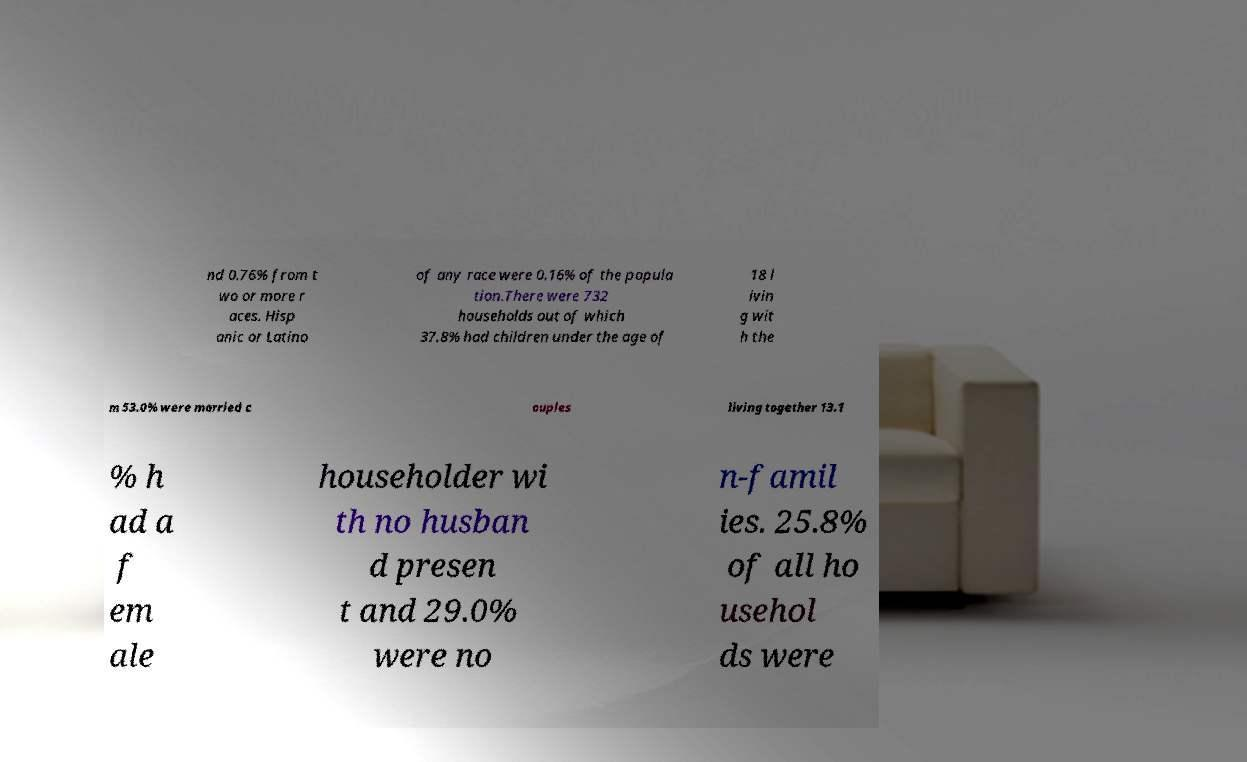Could you assist in decoding the text presented in this image and type it out clearly? nd 0.76% from t wo or more r aces. Hisp anic or Latino of any race were 0.16% of the popula tion.There were 732 households out of which 37.8% had children under the age of 18 l ivin g wit h the m 53.0% were married c ouples living together 13.1 % h ad a f em ale householder wi th no husban d presen t and 29.0% were no n-famil ies. 25.8% of all ho usehol ds were 